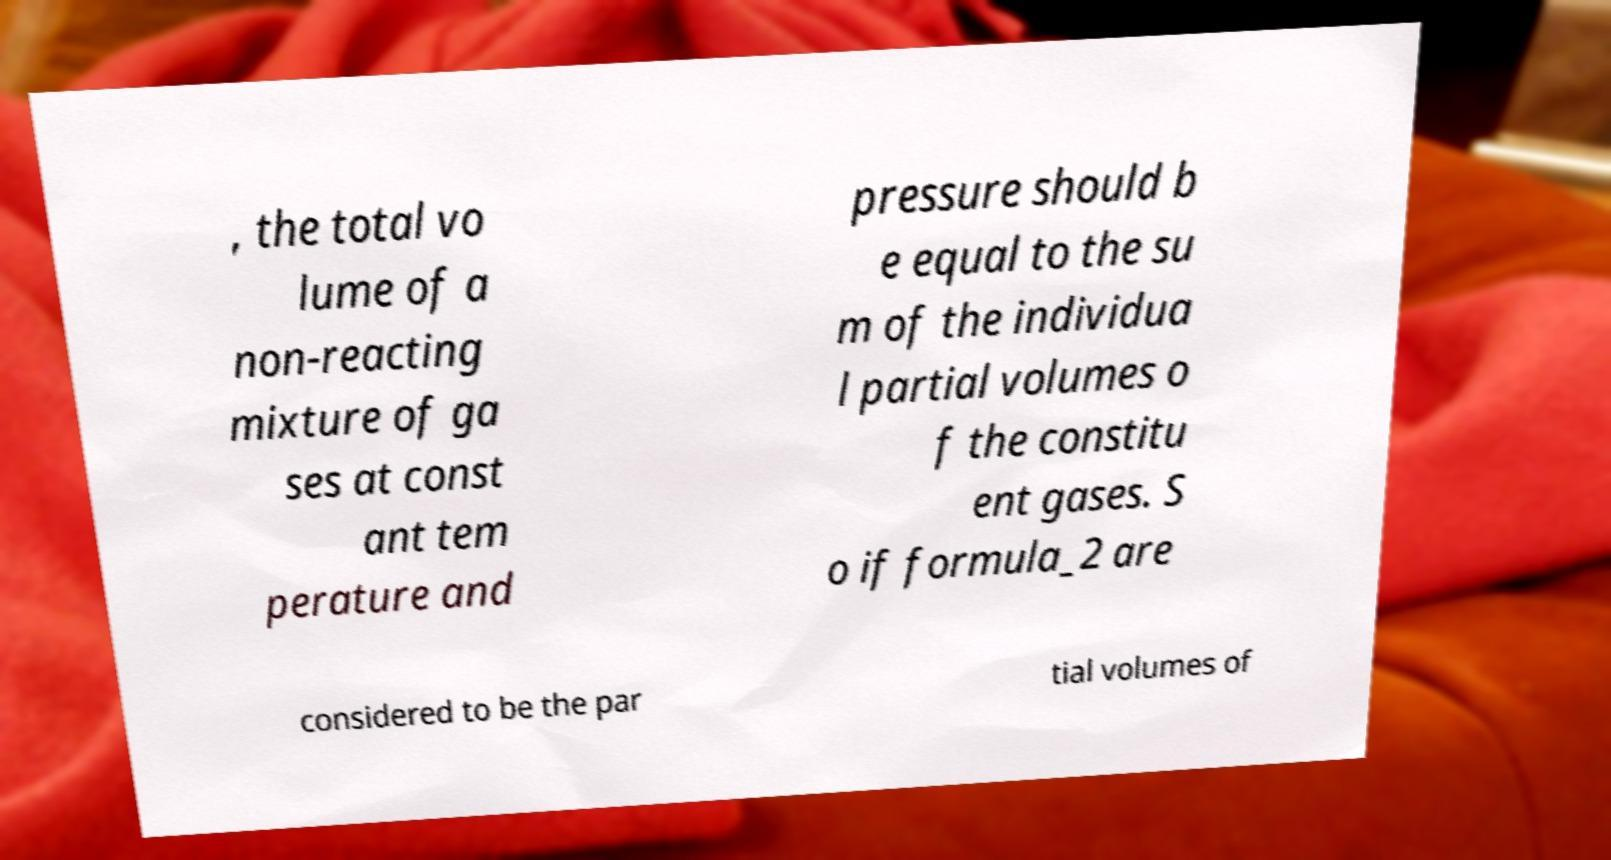For documentation purposes, I need the text within this image transcribed. Could you provide that? , the total vo lume of a non-reacting mixture of ga ses at const ant tem perature and pressure should b e equal to the su m of the individua l partial volumes o f the constitu ent gases. S o if formula_2 are considered to be the par tial volumes of 